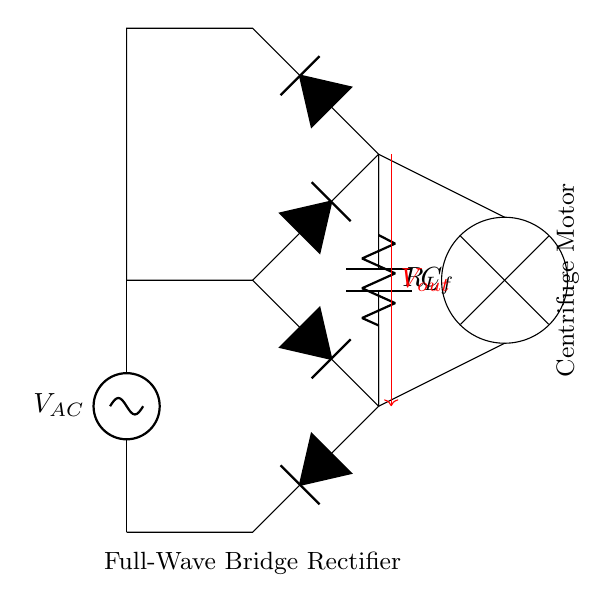What type of rectifier is used in this circuit? The circuit diagram shows a full-wave bridge rectifier, which is indicated by the arrangement of four diodes connected in a bridge configuration. This allows both halves of the AC input signal to be used.
Answer: Full-wave bridge rectifier What is the purpose of the capacitor in this circuit? The capacitor, labeled as C_f, is used for filtering the output voltage to smoothen the DC signal. It charges when the voltage increases and discharges when the voltage decreases, reducing ripple.
Answer: Filtering What component is labeled as R_L? The component labeled R_L represents the load resistor in the circuit, which is designed to consume the power from the rectified output voltage and provide a load for the motor.
Answer: Load resistor What voltage is indicated as V_out? The V_out is connected to the output of the bridge rectifier, which is the output voltage supplied to the load resistor and ultimately to the centrifuge motor, serving as the DC voltage provided by the rectifier.
Answer: Output voltage How many diodes are used in the full-wave bridge rectifier? The bridge rectifier consists of four diodes connected in such a way that two diodes conduct during each half cycle of the input AC waveform. This configuration effectively converts AC to DC.
Answer: Four diodes Which component supplies the AC voltage? The AC voltage supply, indicated as V_AC, is the source providing the alternating current needed for the operation of the bridge rectifier, converting it to a usable DC output for the motor.
Answer: AC voltage supply 